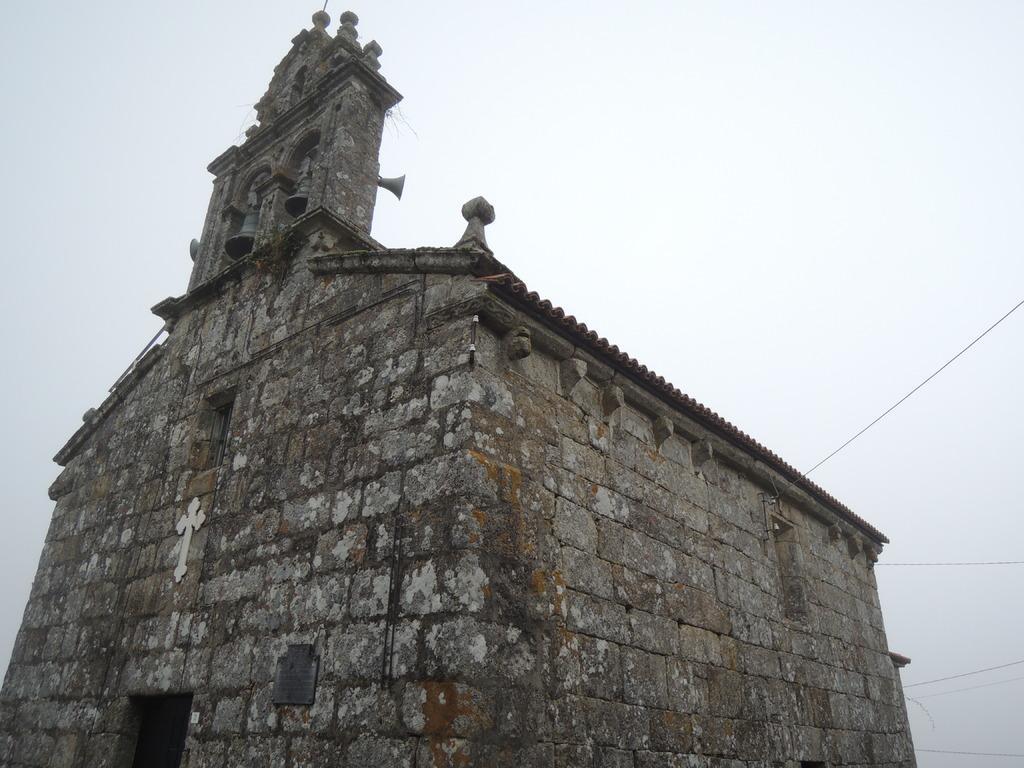Please provide a concise description of this image. In the picture we can see the old church building and behind it, we can see the sky. 